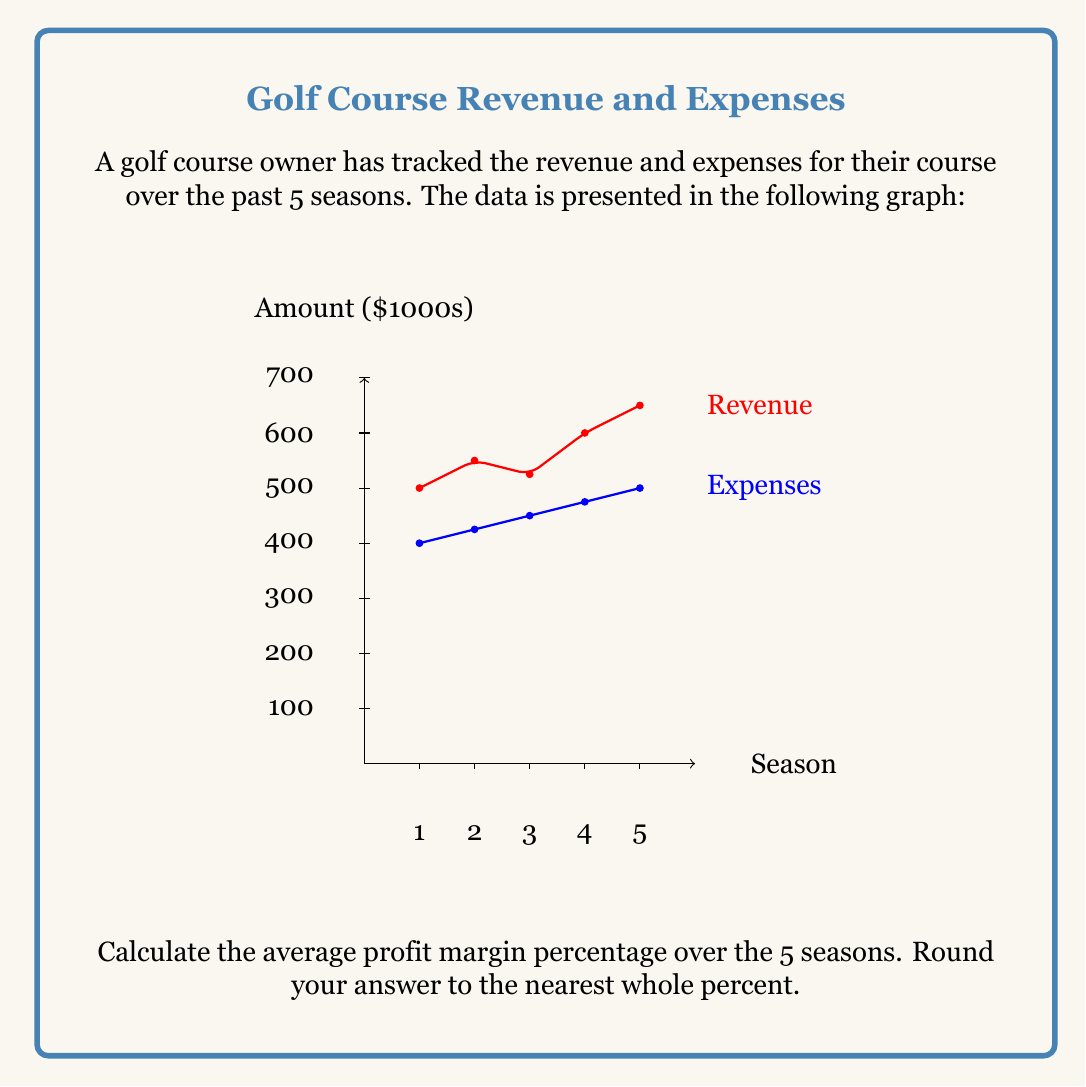What is the answer to this math problem? To solve this problem, we'll follow these steps:

1) First, let's calculate the profit for each season:
   Profit = Revenue - Expenses

   Season 1: $500,000 - $400,000 = $100,000
   Season 2: $550,000 - $425,000 = $125,000
   Season 3: $525,000 - $450,000 = $75,000
   Season 4: $600,000 - $475,000 = $125,000
   Season 5: $650,000 - $500,000 = $150,000

2) Now, let's calculate the profit margin for each season:
   Profit Margin = (Profit / Revenue) * 100%

   Season 1: $(100,000 / 500,000) * 100\% = 20\%$
   Season 2: $(125,000 / 550,000) * 100\% = 22.73\%$
   Season 3: $(75,000 / 525,000) * 100\% = 14.29\%$
   Season 4: $(125,000 / 600,000) * 100\% = 20.83\%$
   Season 5: $(150,000 / 650,000) * 100\% = 23.08\%$

3) To find the average profit margin, we sum all the profit margins and divide by the number of seasons:

   $\frac{20\% + 22.73\% + 14.29\% + 20.83\% + 23.08\%}{5} = 20.19\%$

4) Rounding to the nearest whole percent:
   20.19% rounds to 20%
Answer: 20% 